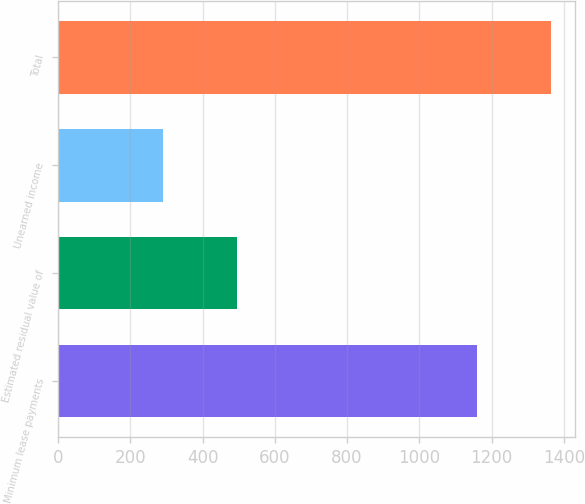Convert chart to OTSL. <chart><loc_0><loc_0><loc_500><loc_500><bar_chart><fcel>Minimum lease payments<fcel>Estimated residual value of<fcel>Unearned income<fcel>Total<nl><fcel>1159<fcel>495<fcel>290<fcel>1364<nl></chart> 